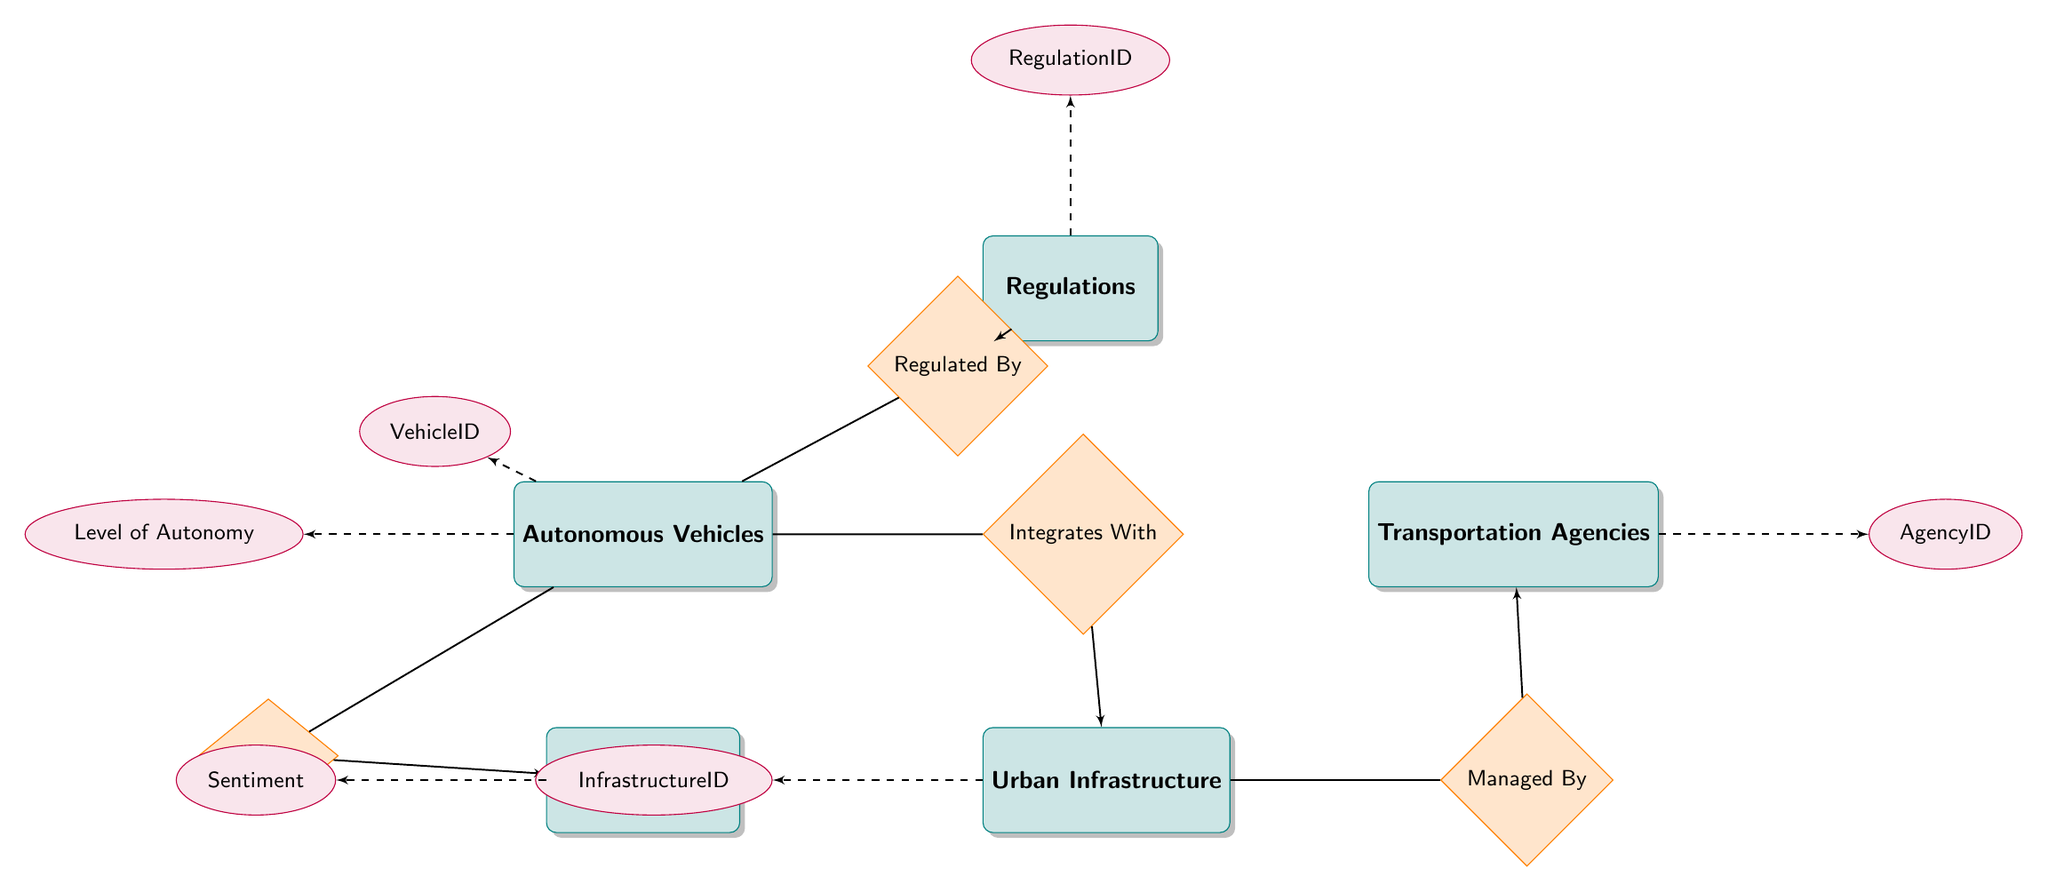What are the main entities represented in the diagram? The diagram shows five main entities: Autonomous Vehicles, Urban Infrastructure, Regulations, Transportation Agencies, and Public Reaction.
Answer: Autonomous Vehicles, Urban Infrastructure, Regulations, Transportation Agencies, Public Reaction What relationship connects Autonomous Vehicles to Urban Infrastructure? The relationship linking Autonomous Vehicles and Urban Infrastructure is 'Integrates With'. This can be observed directly as the line connecting these two entities in the diagram is labeled with this relationship.
Answer: Integrates With How many attributes are associated with Public Reaction? Public Reaction has one attribute listed in the diagram, which is 'Sentiment'. This can be verified by counting the attributes connected to the Public Reaction entity in the diagram.
Answer: 1 Who manages Urban Infrastructure? Urban Infrastructure is managed by Transportation Agencies, as indicated by the 'Managed By' relationship. The visual representation shows a line connecting Urban Infrastructure to Transportation Agencies with this label.
Answer: Transportation Agencies What is the impact of Autonomous Vehicles on Public Reaction? The effect of Autonomous Vehicles on Public Reaction is characterized by the relationship 'Affects', indicating a direct influence. The path from Autonomous Vehicles to Public Reaction is clearly marked with this label in the diagram.
Answer: Affects Which attribute is linked to Regulations? The attribute connected to Regulations is 'RegulationID', as highlighted in the diagram through the dashed line leading from the Regulations entity to its attributes.
Answer: RegulationID What compliance aspect is involved in the relationship between Autonomous Vehicles and Regulations? The compliance aspect in this relationship is represented by the attribute 'ComplianceStatus'. This is shown in the diagram as an attribute associated with the 'Regulated By' relationship.
Answer: ComplianceStatus How many relationships are illustrated in the diagram? There are four relationships illustrated in the diagram. These include 'Integrates With', 'Regulated By', 'Managed By', and 'Affects'. Counting these relationships directly from the diagram will confirm the total number.
Answer: 4 What kind of sentiment is tracked in Public Reaction? The sentiment tracked in Public Reaction is simply categorized as 'Sentiment', as it is the only attribute listed beneath the Public Reaction entity.
Answer: Sentiment 